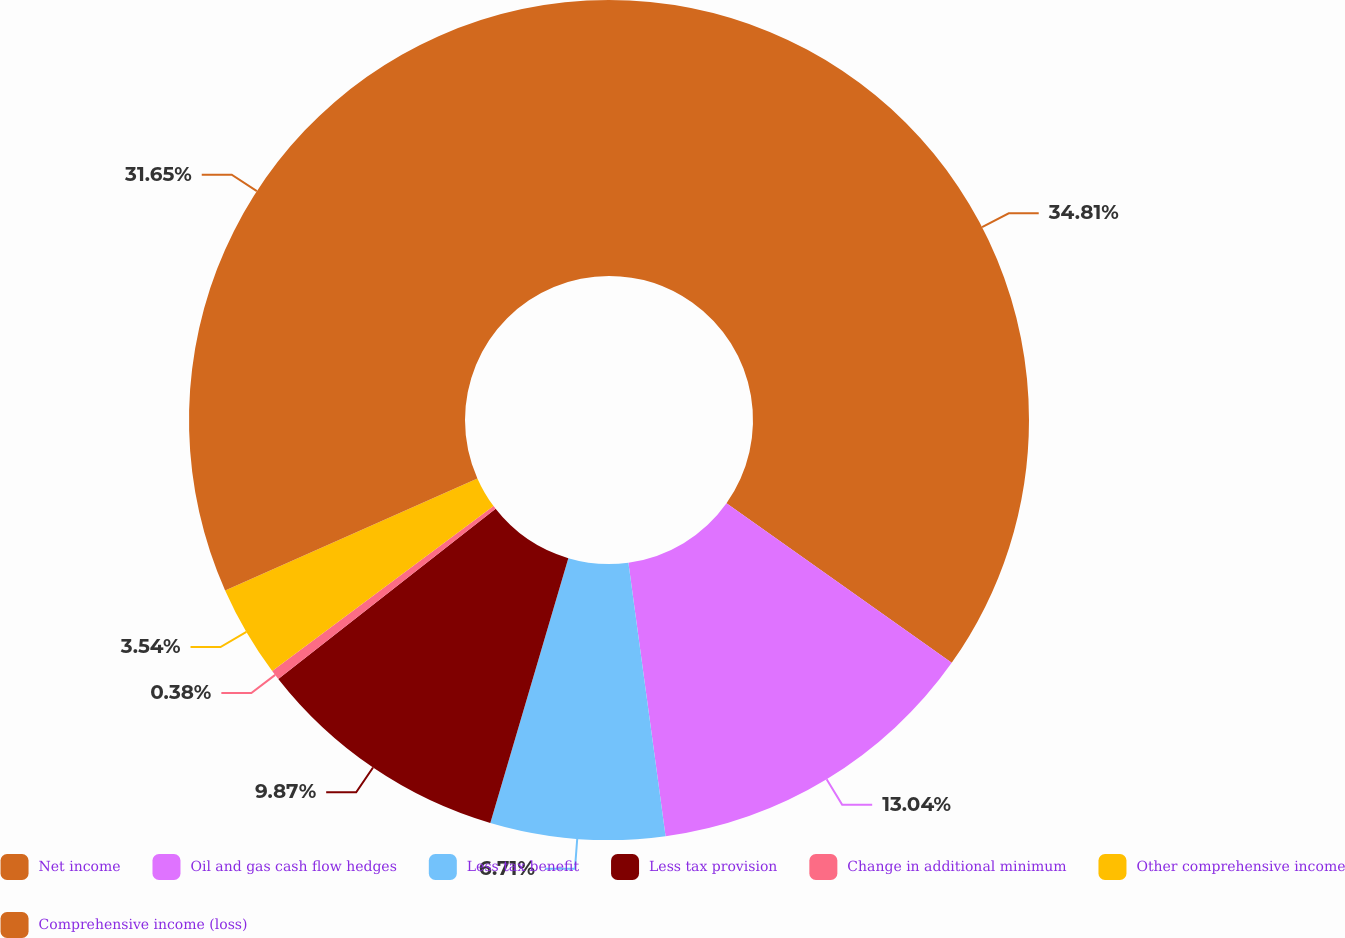Convert chart to OTSL. <chart><loc_0><loc_0><loc_500><loc_500><pie_chart><fcel>Net income<fcel>Oil and gas cash flow hedges<fcel>Less tax benefit<fcel>Less tax provision<fcel>Change in additional minimum<fcel>Other comprehensive income<fcel>Comprehensive income (loss)<nl><fcel>34.81%<fcel>13.04%<fcel>6.71%<fcel>9.87%<fcel>0.38%<fcel>3.54%<fcel>31.65%<nl></chart> 